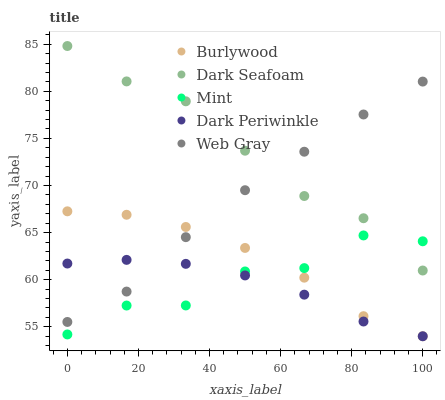Does Dark Periwinkle have the minimum area under the curve?
Answer yes or no. Yes. Does Dark Seafoam have the maximum area under the curve?
Answer yes or no. Yes. Does Web Gray have the minimum area under the curve?
Answer yes or no. No. Does Web Gray have the maximum area under the curve?
Answer yes or no. No. Is Dark Periwinkle the smoothest?
Answer yes or no. Yes. Is Mint the roughest?
Answer yes or no. Yes. Is Dark Seafoam the smoothest?
Answer yes or no. No. Is Dark Seafoam the roughest?
Answer yes or no. No. Does Burlywood have the lowest value?
Answer yes or no. Yes. Does Web Gray have the lowest value?
Answer yes or no. No. Does Dark Seafoam have the highest value?
Answer yes or no. Yes. Does Web Gray have the highest value?
Answer yes or no. No. Is Mint less than Web Gray?
Answer yes or no. Yes. Is Dark Seafoam greater than Burlywood?
Answer yes or no. Yes. Does Dark Seafoam intersect Mint?
Answer yes or no. Yes. Is Dark Seafoam less than Mint?
Answer yes or no. No. Is Dark Seafoam greater than Mint?
Answer yes or no. No. Does Mint intersect Web Gray?
Answer yes or no. No. 